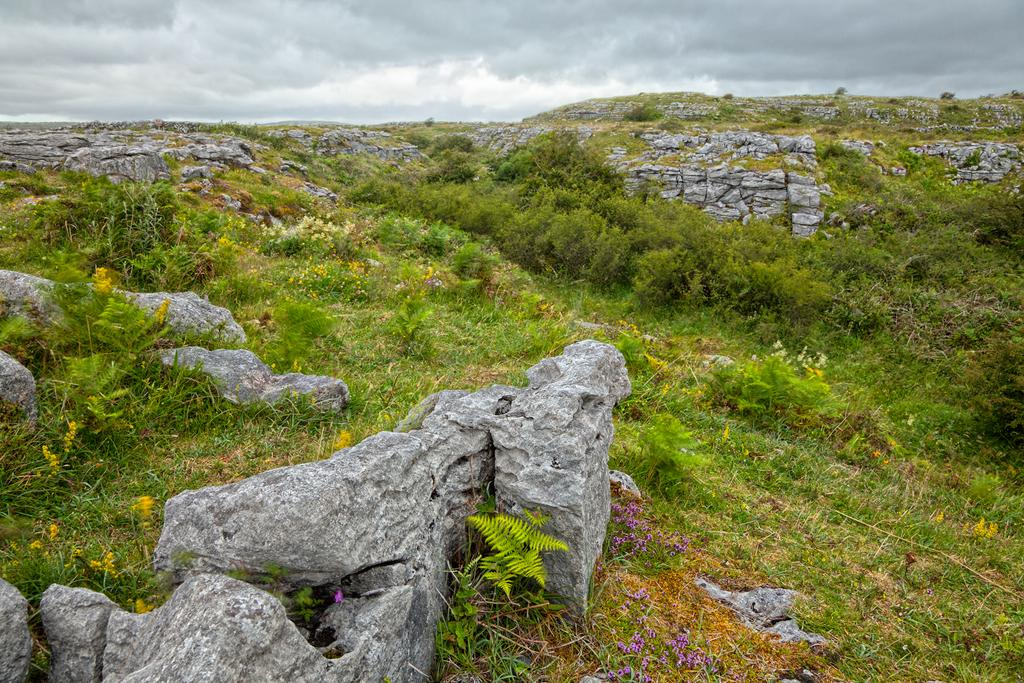What type of natural elements can be seen in the image? There are rocks and plants in the image. What is visible in the background of the image? The sky is visible in the background of the image. What type of street can be seen in the image? There is no street present in the image; it features rocks, plants, and the sky. What color is the scarf that the plant is wearing in the image? Plants do not wear scarves, so this detail cannot be found in the image. 